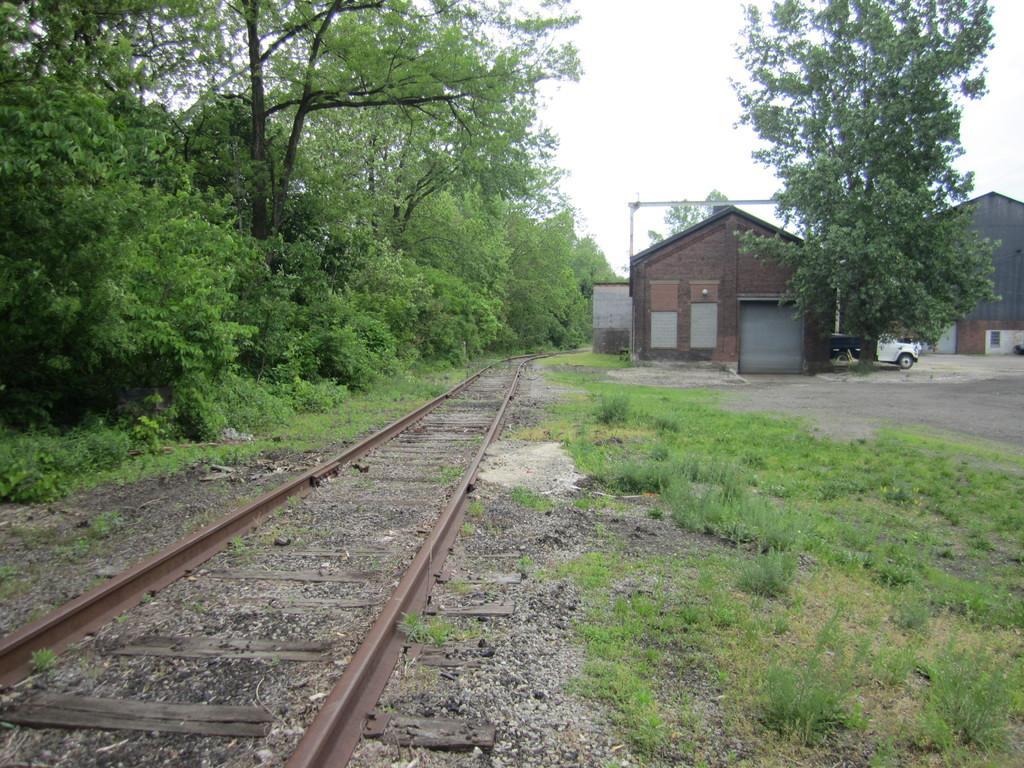Could you give a brief overview of what you see in this image? As we can see in the image there are trees and houses. There is grass, railway track, white color car and at the top there is sky. 